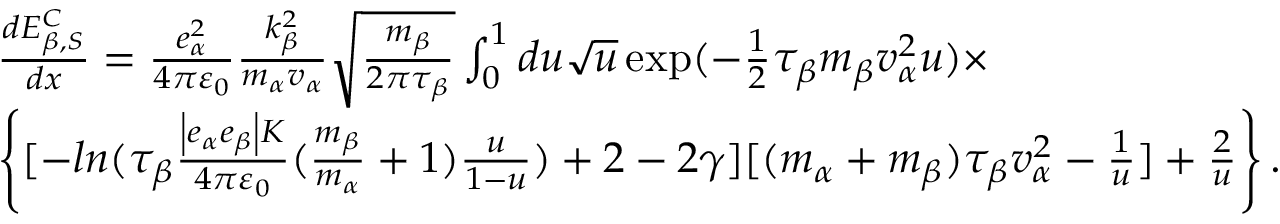Convert formula to latex. <formula><loc_0><loc_0><loc_500><loc_500>\begin{array} { r l } & { \frac { d E _ { \beta , S } ^ { C } } { d x } = \frac { e _ { \alpha } ^ { 2 } } { 4 \pi { { \varepsilon } _ { 0 } } } \frac { k _ { \beta } ^ { 2 } } { { { m } _ { \alpha } } { { v } _ { \alpha } } } \sqrt { \frac { { { m } _ { \beta } } } { 2 \pi { { \tau } _ { \beta } } } } \int _ { 0 } ^ { 1 } { d u \sqrt { u } } \exp ( - \frac { 1 } { 2 } { { \tau } _ { \beta } } { { m } _ { \beta } } v _ { \alpha } ^ { 2 } u ) \times } \\ & { \left \{ [ - \ln ( { { \tau } _ { \beta } } \frac { \left | { { e } _ { \alpha } } { { e } _ { \beta } } \right | K } { 4 \pi { { \varepsilon } _ { 0 } } } ( \frac { { { m } _ { \beta } } } { { { m } _ { \alpha } } } + 1 ) \frac { u } { 1 - u } ) + 2 - 2 \gamma ] [ ( { { m } _ { \alpha } } + { { m } _ { \beta } } ) { { \tau } _ { \beta } } v _ { \alpha } ^ { 2 } - \frac { 1 } { u } ] + \frac { 2 } { u } \right \} . } \end{array}</formula> 